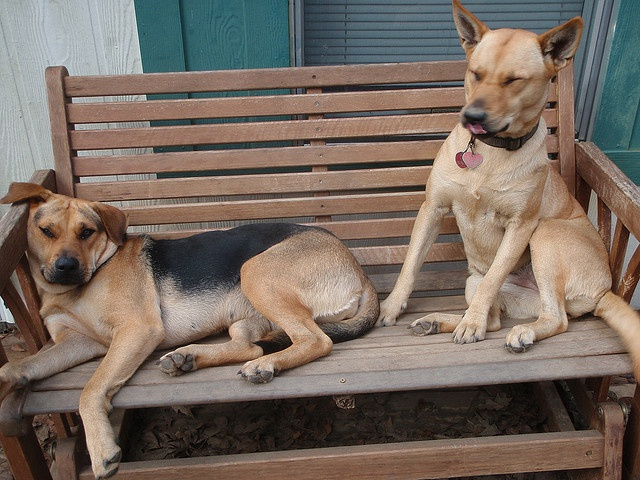Describe the objects in this image and their specific colors. I can see bench in darkgray, gray, and black tones, dog in darkgray, gray, black, and tan tones, and dog in darkgray, tan, and gray tones in this image. 